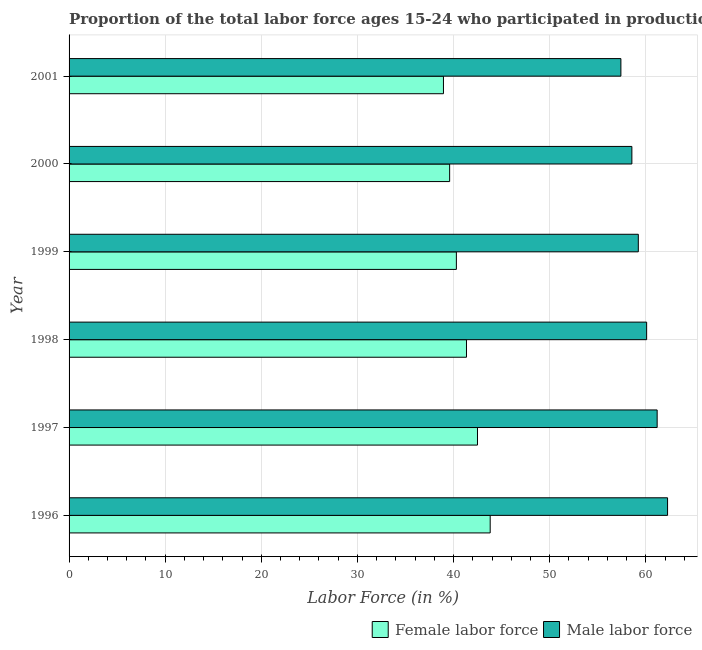How many different coloured bars are there?
Provide a succinct answer. 2. How many groups of bars are there?
Provide a succinct answer. 6. Are the number of bars per tick equal to the number of legend labels?
Ensure brevity in your answer.  Yes. Are the number of bars on each tick of the Y-axis equal?
Give a very brief answer. Yes. How many bars are there on the 3rd tick from the top?
Give a very brief answer. 2. How many bars are there on the 4th tick from the bottom?
Offer a very short reply. 2. What is the label of the 1st group of bars from the top?
Your answer should be very brief. 2001. What is the percentage of female labor force in 1996?
Your answer should be compact. 43.81. Across all years, what is the maximum percentage of male labour force?
Provide a short and direct response. 62.27. Across all years, what is the minimum percentage of male labour force?
Ensure brevity in your answer.  57.41. In which year was the percentage of female labor force maximum?
Offer a very short reply. 1996. In which year was the percentage of male labour force minimum?
Keep it short and to the point. 2001. What is the total percentage of female labor force in the graph?
Provide a succinct answer. 246.48. What is the difference between the percentage of male labour force in 1996 and that in 1999?
Keep it short and to the point. 3.04. What is the difference between the percentage of female labor force in 1996 and the percentage of male labour force in 1999?
Provide a short and direct response. -15.41. What is the average percentage of male labour force per year?
Provide a short and direct response. 59.79. In the year 1998, what is the difference between the percentage of female labor force and percentage of male labour force?
Ensure brevity in your answer.  -18.74. What is the ratio of the percentage of male labour force in 1996 to that in 1998?
Your answer should be very brief. 1.04. Is the percentage of female labor force in 1996 less than that in 1998?
Make the answer very short. No. What is the difference between the highest and the second highest percentage of male labour force?
Provide a succinct answer. 1.08. What is the difference between the highest and the lowest percentage of male labour force?
Offer a very short reply. 4.86. Is the sum of the percentage of male labour force in 1996 and 1998 greater than the maximum percentage of female labor force across all years?
Your answer should be very brief. Yes. What does the 1st bar from the top in 1997 represents?
Provide a succinct answer. Male labor force. What does the 1st bar from the bottom in 2001 represents?
Ensure brevity in your answer.  Female labor force. How many bars are there?
Your answer should be very brief. 12. Are all the bars in the graph horizontal?
Your response must be concise. Yes. How many years are there in the graph?
Give a very brief answer. 6. What is the difference between two consecutive major ticks on the X-axis?
Offer a very short reply. 10. Are the values on the major ticks of X-axis written in scientific E-notation?
Your answer should be very brief. No. Where does the legend appear in the graph?
Ensure brevity in your answer.  Bottom right. How many legend labels are there?
Provide a succinct answer. 2. What is the title of the graph?
Your answer should be very brief. Proportion of the total labor force ages 15-24 who participated in production in Caribbean small states. Does "Secondary" appear as one of the legend labels in the graph?
Your answer should be compact. No. What is the Labor Force (in %) of Female labor force in 1996?
Your answer should be very brief. 43.81. What is the Labor Force (in %) of Male labor force in 1996?
Keep it short and to the point. 62.27. What is the Labor Force (in %) in Female labor force in 1997?
Provide a succinct answer. 42.49. What is the Labor Force (in %) of Male labor force in 1997?
Ensure brevity in your answer.  61.18. What is the Labor Force (in %) in Female labor force in 1998?
Provide a succinct answer. 41.35. What is the Labor Force (in %) in Male labor force in 1998?
Your response must be concise. 60.09. What is the Labor Force (in %) in Female labor force in 1999?
Provide a short and direct response. 40.29. What is the Labor Force (in %) in Male labor force in 1999?
Your response must be concise. 59.22. What is the Labor Force (in %) in Female labor force in 2000?
Offer a very short reply. 39.59. What is the Labor Force (in %) in Male labor force in 2000?
Keep it short and to the point. 58.55. What is the Labor Force (in %) in Female labor force in 2001?
Provide a succinct answer. 38.95. What is the Labor Force (in %) in Male labor force in 2001?
Provide a succinct answer. 57.41. Across all years, what is the maximum Labor Force (in %) in Female labor force?
Your response must be concise. 43.81. Across all years, what is the maximum Labor Force (in %) of Male labor force?
Ensure brevity in your answer.  62.27. Across all years, what is the minimum Labor Force (in %) of Female labor force?
Make the answer very short. 38.95. Across all years, what is the minimum Labor Force (in %) in Male labor force?
Offer a very short reply. 57.41. What is the total Labor Force (in %) in Female labor force in the graph?
Keep it short and to the point. 246.48. What is the total Labor Force (in %) of Male labor force in the graph?
Offer a terse response. 358.72. What is the difference between the Labor Force (in %) in Female labor force in 1996 and that in 1997?
Keep it short and to the point. 1.32. What is the difference between the Labor Force (in %) of Male labor force in 1996 and that in 1997?
Provide a short and direct response. 1.08. What is the difference between the Labor Force (in %) of Female labor force in 1996 and that in 1998?
Your response must be concise. 2.46. What is the difference between the Labor Force (in %) of Male labor force in 1996 and that in 1998?
Provide a succinct answer. 2.18. What is the difference between the Labor Force (in %) of Female labor force in 1996 and that in 1999?
Keep it short and to the point. 3.52. What is the difference between the Labor Force (in %) in Male labor force in 1996 and that in 1999?
Keep it short and to the point. 3.04. What is the difference between the Labor Force (in %) in Female labor force in 1996 and that in 2000?
Ensure brevity in your answer.  4.22. What is the difference between the Labor Force (in %) in Male labor force in 1996 and that in 2000?
Give a very brief answer. 3.71. What is the difference between the Labor Force (in %) of Female labor force in 1996 and that in 2001?
Provide a short and direct response. 4.86. What is the difference between the Labor Force (in %) in Male labor force in 1996 and that in 2001?
Provide a succinct answer. 4.86. What is the difference between the Labor Force (in %) of Female labor force in 1997 and that in 1998?
Provide a short and direct response. 1.14. What is the difference between the Labor Force (in %) of Male labor force in 1997 and that in 1998?
Provide a short and direct response. 1.09. What is the difference between the Labor Force (in %) of Female labor force in 1997 and that in 1999?
Provide a short and direct response. 2.2. What is the difference between the Labor Force (in %) of Male labor force in 1997 and that in 1999?
Your answer should be very brief. 1.96. What is the difference between the Labor Force (in %) in Female labor force in 1997 and that in 2000?
Make the answer very short. 2.9. What is the difference between the Labor Force (in %) of Male labor force in 1997 and that in 2000?
Keep it short and to the point. 2.63. What is the difference between the Labor Force (in %) in Female labor force in 1997 and that in 2001?
Give a very brief answer. 3.54. What is the difference between the Labor Force (in %) of Male labor force in 1997 and that in 2001?
Your answer should be compact. 3.77. What is the difference between the Labor Force (in %) of Female labor force in 1998 and that in 1999?
Keep it short and to the point. 1.05. What is the difference between the Labor Force (in %) in Male labor force in 1998 and that in 1999?
Offer a very short reply. 0.87. What is the difference between the Labor Force (in %) of Female labor force in 1998 and that in 2000?
Give a very brief answer. 1.75. What is the difference between the Labor Force (in %) in Male labor force in 1998 and that in 2000?
Your answer should be very brief. 1.53. What is the difference between the Labor Force (in %) of Female labor force in 1998 and that in 2001?
Give a very brief answer. 2.4. What is the difference between the Labor Force (in %) in Male labor force in 1998 and that in 2001?
Your answer should be very brief. 2.68. What is the difference between the Labor Force (in %) of Female labor force in 1999 and that in 2000?
Provide a succinct answer. 0.7. What is the difference between the Labor Force (in %) of Male labor force in 1999 and that in 2000?
Offer a very short reply. 0.67. What is the difference between the Labor Force (in %) of Female labor force in 1999 and that in 2001?
Ensure brevity in your answer.  1.34. What is the difference between the Labor Force (in %) of Male labor force in 1999 and that in 2001?
Provide a succinct answer. 1.81. What is the difference between the Labor Force (in %) in Female labor force in 2000 and that in 2001?
Offer a terse response. 0.64. What is the difference between the Labor Force (in %) in Male labor force in 2000 and that in 2001?
Keep it short and to the point. 1.14. What is the difference between the Labor Force (in %) of Female labor force in 1996 and the Labor Force (in %) of Male labor force in 1997?
Provide a succinct answer. -17.37. What is the difference between the Labor Force (in %) of Female labor force in 1996 and the Labor Force (in %) of Male labor force in 1998?
Your answer should be very brief. -16.28. What is the difference between the Labor Force (in %) in Female labor force in 1996 and the Labor Force (in %) in Male labor force in 1999?
Your answer should be compact. -15.41. What is the difference between the Labor Force (in %) of Female labor force in 1996 and the Labor Force (in %) of Male labor force in 2000?
Your answer should be compact. -14.74. What is the difference between the Labor Force (in %) of Female labor force in 1996 and the Labor Force (in %) of Male labor force in 2001?
Provide a succinct answer. -13.6. What is the difference between the Labor Force (in %) in Female labor force in 1997 and the Labor Force (in %) in Male labor force in 1998?
Provide a short and direct response. -17.6. What is the difference between the Labor Force (in %) in Female labor force in 1997 and the Labor Force (in %) in Male labor force in 1999?
Your answer should be very brief. -16.73. What is the difference between the Labor Force (in %) in Female labor force in 1997 and the Labor Force (in %) in Male labor force in 2000?
Keep it short and to the point. -16.06. What is the difference between the Labor Force (in %) in Female labor force in 1997 and the Labor Force (in %) in Male labor force in 2001?
Make the answer very short. -14.92. What is the difference between the Labor Force (in %) of Female labor force in 1998 and the Labor Force (in %) of Male labor force in 1999?
Your response must be concise. -17.88. What is the difference between the Labor Force (in %) of Female labor force in 1998 and the Labor Force (in %) of Male labor force in 2000?
Give a very brief answer. -17.21. What is the difference between the Labor Force (in %) in Female labor force in 1998 and the Labor Force (in %) in Male labor force in 2001?
Your response must be concise. -16.06. What is the difference between the Labor Force (in %) in Female labor force in 1999 and the Labor Force (in %) in Male labor force in 2000?
Your answer should be very brief. -18.26. What is the difference between the Labor Force (in %) of Female labor force in 1999 and the Labor Force (in %) of Male labor force in 2001?
Keep it short and to the point. -17.12. What is the difference between the Labor Force (in %) of Female labor force in 2000 and the Labor Force (in %) of Male labor force in 2001?
Keep it short and to the point. -17.82. What is the average Labor Force (in %) in Female labor force per year?
Make the answer very short. 41.08. What is the average Labor Force (in %) of Male labor force per year?
Your answer should be very brief. 59.79. In the year 1996, what is the difference between the Labor Force (in %) in Female labor force and Labor Force (in %) in Male labor force?
Keep it short and to the point. -18.45. In the year 1997, what is the difference between the Labor Force (in %) of Female labor force and Labor Force (in %) of Male labor force?
Offer a terse response. -18.69. In the year 1998, what is the difference between the Labor Force (in %) in Female labor force and Labor Force (in %) in Male labor force?
Offer a very short reply. -18.74. In the year 1999, what is the difference between the Labor Force (in %) in Female labor force and Labor Force (in %) in Male labor force?
Keep it short and to the point. -18.93. In the year 2000, what is the difference between the Labor Force (in %) in Female labor force and Labor Force (in %) in Male labor force?
Make the answer very short. -18.96. In the year 2001, what is the difference between the Labor Force (in %) in Female labor force and Labor Force (in %) in Male labor force?
Your answer should be very brief. -18.46. What is the ratio of the Labor Force (in %) in Female labor force in 1996 to that in 1997?
Your response must be concise. 1.03. What is the ratio of the Labor Force (in %) of Male labor force in 1996 to that in 1997?
Offer a terse response. 1.02. What is the ratio of the Labor Force (in %) in Female labor force in 1996 to that in 1998?
Your answer should be compact. 1.06. What is the ratio of the Labor Force (in %) in Male labor force in 1996 to that in 1998?
Offer a very short reply. 1.04. What is the ratio of the Labor Force (in %) in Female labor force in 1996 to that in 1999?
Ensure brevity in your answer.  1.09. What is the ratio of the Labor Force (in %) of Male labor force in 1996 to that in 1999?
Make the answer very short. 1.05. What is the ratio of the Labor Force (in %) in Female labor force in 1996 to that in 2000?
Keep it short and to the point. 1.11. What is the ratio of the Labor Force (in %) of Male labor force in 1996 to that in 2000?
Provide a short and direct response. 1.06. What is the ratio of the Labor Force (in %) in Female labor force in 1996 to that in 2001?
Give a very brief answer. 1.12. What is the ratio of the Labor Force (in %) in Male labor force in 1996 to that in 2001?
Give a very brief answer. 1.08. What is the ratio of the Labor Force (in %) in Female labor force in 1997 to that in 1998?
Your answer should be very brief. 1.03. What is the ratio of the Labor Force (in %) of Male labor force in 1997 to that in 1998?
Your answer should be very brief. 1.02. What is the ratio of the Labor Force (in %) in Female labor force in 1997 to that in 1999?
Offer a very short reply. 1.05. What is the ratio of the Labor Force (in %) in Male labor force in 1997 to that in 1999?
Keep it short and to the point. 1.03. What is the ratio of the Labor Force (in %) of Female labor force in 1997 to that in 2000?
Ensure brevity in your answer.  1.07. What is the ratio of the Labor Force (in %) of Male labor force in 1997 to that in 2000?
Make the answer very short. 1.04. What is the ratio of the Labor Force (in %) of Male labor force in 1997 to that in 2001?
Offer a terse response. 1.07. What is the ratio of the Labor Force (in %) of Female labor force in 1998 to that in 1999?
Your answer should be very brief. 1.03. What is the ratio of the Labor Force (in %) in Male labor force in 1998 to that in 1999?
Give a very brief answer. 1.01. What is the ratio of the Labor Force (in %) of Female labor force in 1998 to that in 2000?
Provide a succinct answer. 1.04. What is the ratio of the Labor Force (in %) of Male labor force in 1998 to that in 2000?
Your answer should be very brief. 1.03. What is the ratio of the Labor Force (in %) of Female labor force in 1998 to that in 2001?
Ensure brevity in your answer.  1.06. What is the ratio of the Labor Force (in %) in Male labor force in 1998 to that in 2001?
Your answer should be compact. 1.05. What is the ratio of the Labor Force (in %) of Female labor force in 1999 to that in 2000?
Ensure brevity in your answer.  1.02. What is the ratio of the Labor Force (in %) in Male labor force in 1999 to that in 2000?
Offer a very short reply. 1.01. What is the ratio of the Labor Force (in %) of Female labor force in 1999 to that in 2001?
Offer a terse response. 1.03. What is the ratio of the Labor Force (in %) in Male labor force in 1999 to that in 2001?
Your answer should be very brief. 1.03. What is the ratio of the Labor Force (in %) in Female labor force in 2000 to that in 2001?
Ensure brevity in your answer.  1.02. What is the ratio of the Labor Force (in %) in Male labor force in 2000 to that in 2001?
Ensure brevity in your answer.  1.02. What is the difference between the highest and the second highest Labor Force (in %) of Female labor force?
Provide a short and direct response. 1.32. What is the difference between the highest and the second highest Labor Force (in %) of Male labor force?
Give a very brief answer. 1.08. What is the difference between the highest and the lowest Labor Force (in %) in Female labor force?
Your response must be concise. 4.86. What is the difference between the highest and the lowest Labor Force (in %) in Male labor force?
Your response must be concise. 4.86. 